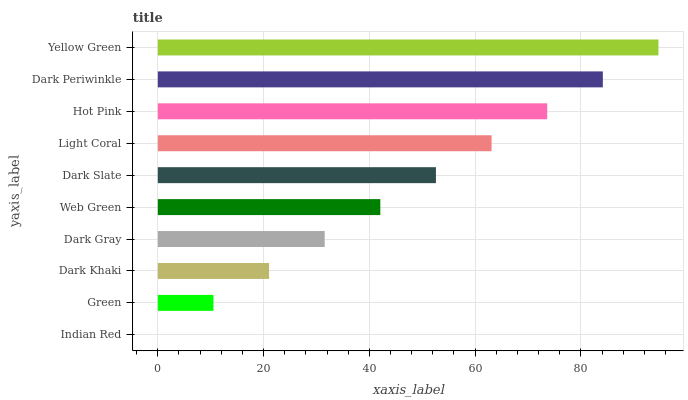Is Indian Red the minimum?
Answer yes or no. Yes. Is Yellow Green the maximum?
Answer yes or no. Yes. Is Green the minimum?
Answer yes or no. No. Is Green the maximum?
Answer yes or no. No. Is Green greater than Indian Red?
Answer yes or no. Yes. Is Indian Red less than Green?
Answer yes or no. Yes. Is Indian Red greater than Green?
Answer yes or no. No. Is Green less than Indian Red?
Answer yes or no. No. Is Dark Slate the high median?
Answer yes or no. Yes. Is Web Green the low median?
Answer yes or no. Yes. Is Light Coral the high median?
Answer yes or no. No. Is Dark Slate the low median?
Answer yes or no. No. 